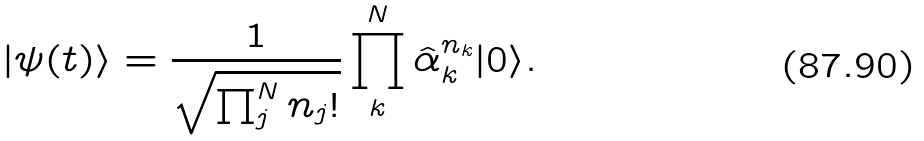<formula> <loc_0><loc_0><loc_500><loc_500>| \psi ( t ) \rangle = \frac { 1 } { \sqrt { \prod _ { j } ^ { N } n _ { j } ! } } \prod _ { k } ^ { N } \hat { \alpha } _ { k } ^ { n _ { k } } | 0 \rangle .</formula> 